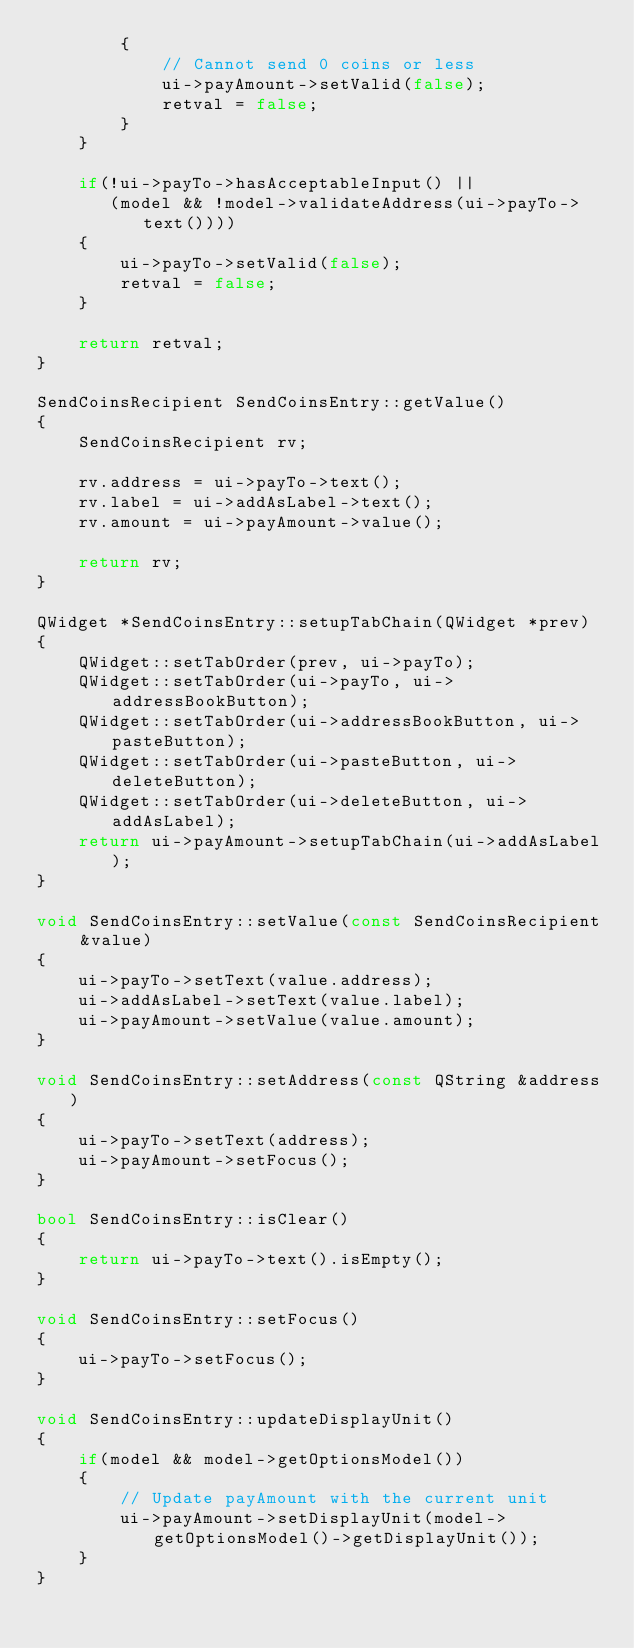Convert code to text. <code><loc_0><loc_0><loc_500><loc_500><_C++_>        {
            // Cannot send 0 coins or less
            ui->payAmount->setValid(false);
            retval = false;
        }
    }

    if(!ui->payTo->hasAcceptableInput() ||
       (model && !model->validateAddress(ui->payTo->text())))
    {
        ui->payTo->setValid(false);
        retval = false;
    }

    return retval;
}

SendCoinsRecipient SendCoinsEntry::getValue()
{
    SendCoinsRecipient rv;

    rv.address = ui->payTo->text();
    rv.label = ui->addAsLabel->text();
    rv.amount = ui->payAmount->value();

    return rv;
}

QWidget *SendCoinsEntry::setupTabChain(QWidget *prev)
{
    QWidget::setTabOrder(prev, ui->payTo);
    QWidget::setTabOrder(ui->payTo, ui->addressBookButton);
    QWidget::setTabOrder(ui->addressBookButton, ui->pasteButton);
    QWidget::setTabOrder(ui->pasteButton, ui->deleteButton);
    QWidget::setTabOrder(ui->deleteButton, ui->addAsLabel);
    return ui->payAmount->setupTabChain(ui->addAsLabel);
}

void SendCoinsEntry::setValue(const SendCoinsRecipient &value)
{
    ui->payTo->setText(value.address);
    ui->addAsLabel->setText(value.label);
    ui->payAmount->setValue(value.amount);
}

void SendCoinsEntry::setAddress(const QString &address)
{
    ui->payTo->setText(address);
    ui->payAmount->setFocus();
}

bool SendCoinsEntry::isClear()
{
    return ui->payTo->text().isEmpty();
}

void SendCoinsEntry::setFocus()
{
    ui->payTo->setFocus();
}

void SendCoinsEntry::updateDisplayUnit()
{
    if(model && model->getOptionsModel())
    {
        // Update payAmount with the current unit
        ui->payAmount->setDisplayUnit(model->getOptionsModel()->getDisplayUnit());
    }
}
</code> 